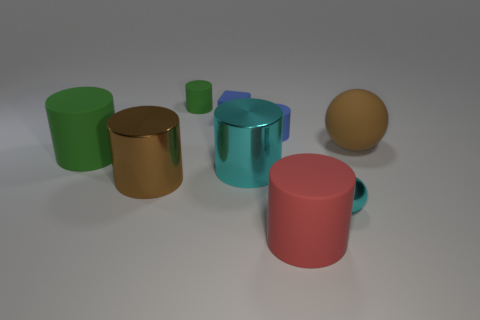There is a brown thing that is to the right of the green rubber cylinder on the right side of the brown cylinder; what is its shape?
Offer a very short reply. Sphere. What number of purple objects are small metallic things or matte balls?
Keep it short and to the point. 0. There is a green rubber thing behind the green thing that is in front of the large brown sphere; is there a big brown shiny thing that is on the right side of it?
Offer a terse response. No. Are there any other things that have the same material as the big cyan cylinder?
Provide a succinct answer. Yes. How many tiny things are either purple metallic cylinders or cyan metal cylinders?
Ensure brevity in your answer.  0. There is a tiny metal object right of the red matte thing; is its shape the same as the brown matte object?
Give a very brief answer. Yes. Is the number of metal spheres less than the number of large shiny things?
Offer a terse response. Yes. Are there any other things that have the same color as the rubber block?
Offer a very short reply. Yes. What is the shape of the large rubber object that is to the left of the red cylinder?
Provide a succinct answer. Cylinder. Is the color of the small matte block the same as the sphere that is in front of the big green object?
Offer a very short reply. No. 